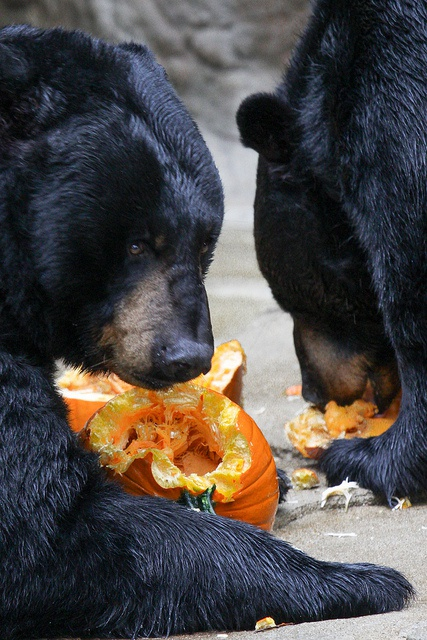Describe the objects in this image and their specific colors. I can see bear in black, gray, and darkblue tones and bear in black, gray, and darkblue tones in this image. 